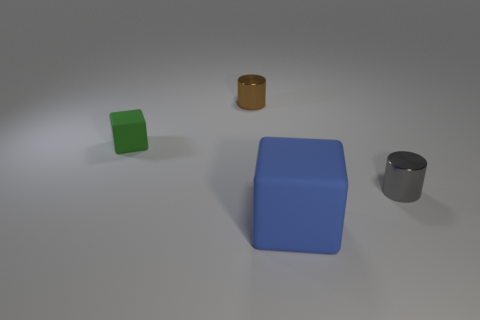Are there any other things that have the same size as the blue cube?
Provide a short and direct response. No. There is a small cylinder that is behind the small thing that is on the right side of the blue rubber thing; are there any blue rubber objects that are on the left side of it?
Provide a succinct answer. No. What number of big blue rubber objects are there?
Make the answer very short. 1. How many objects are either metal objects on the right side of the large blue rubber thing or cylinders behind the gray cylinder?
Your answer should be compact. 2. Do the matte object to the right of the green matte thing and the tiny green thing have the same size?
Provide a short and direct response. No. There is another object that is the same shape as the tiny brown metallic object; what is its size?
Offer a very short reply. Small. There is a brown thing that is the same size as the gray shiny thing; what is its material?
Your answer should be very brief. Metal. There is a tiny gray object that is the same shape as the brown metallic object; what is it made of?
Offer a terse response. Metal. How many other things are there of the same size as the green cube?
Make the answer very short. 2. How many tiny things have the same color as the large rubber thing?
Your answer should be very brief. 0. 